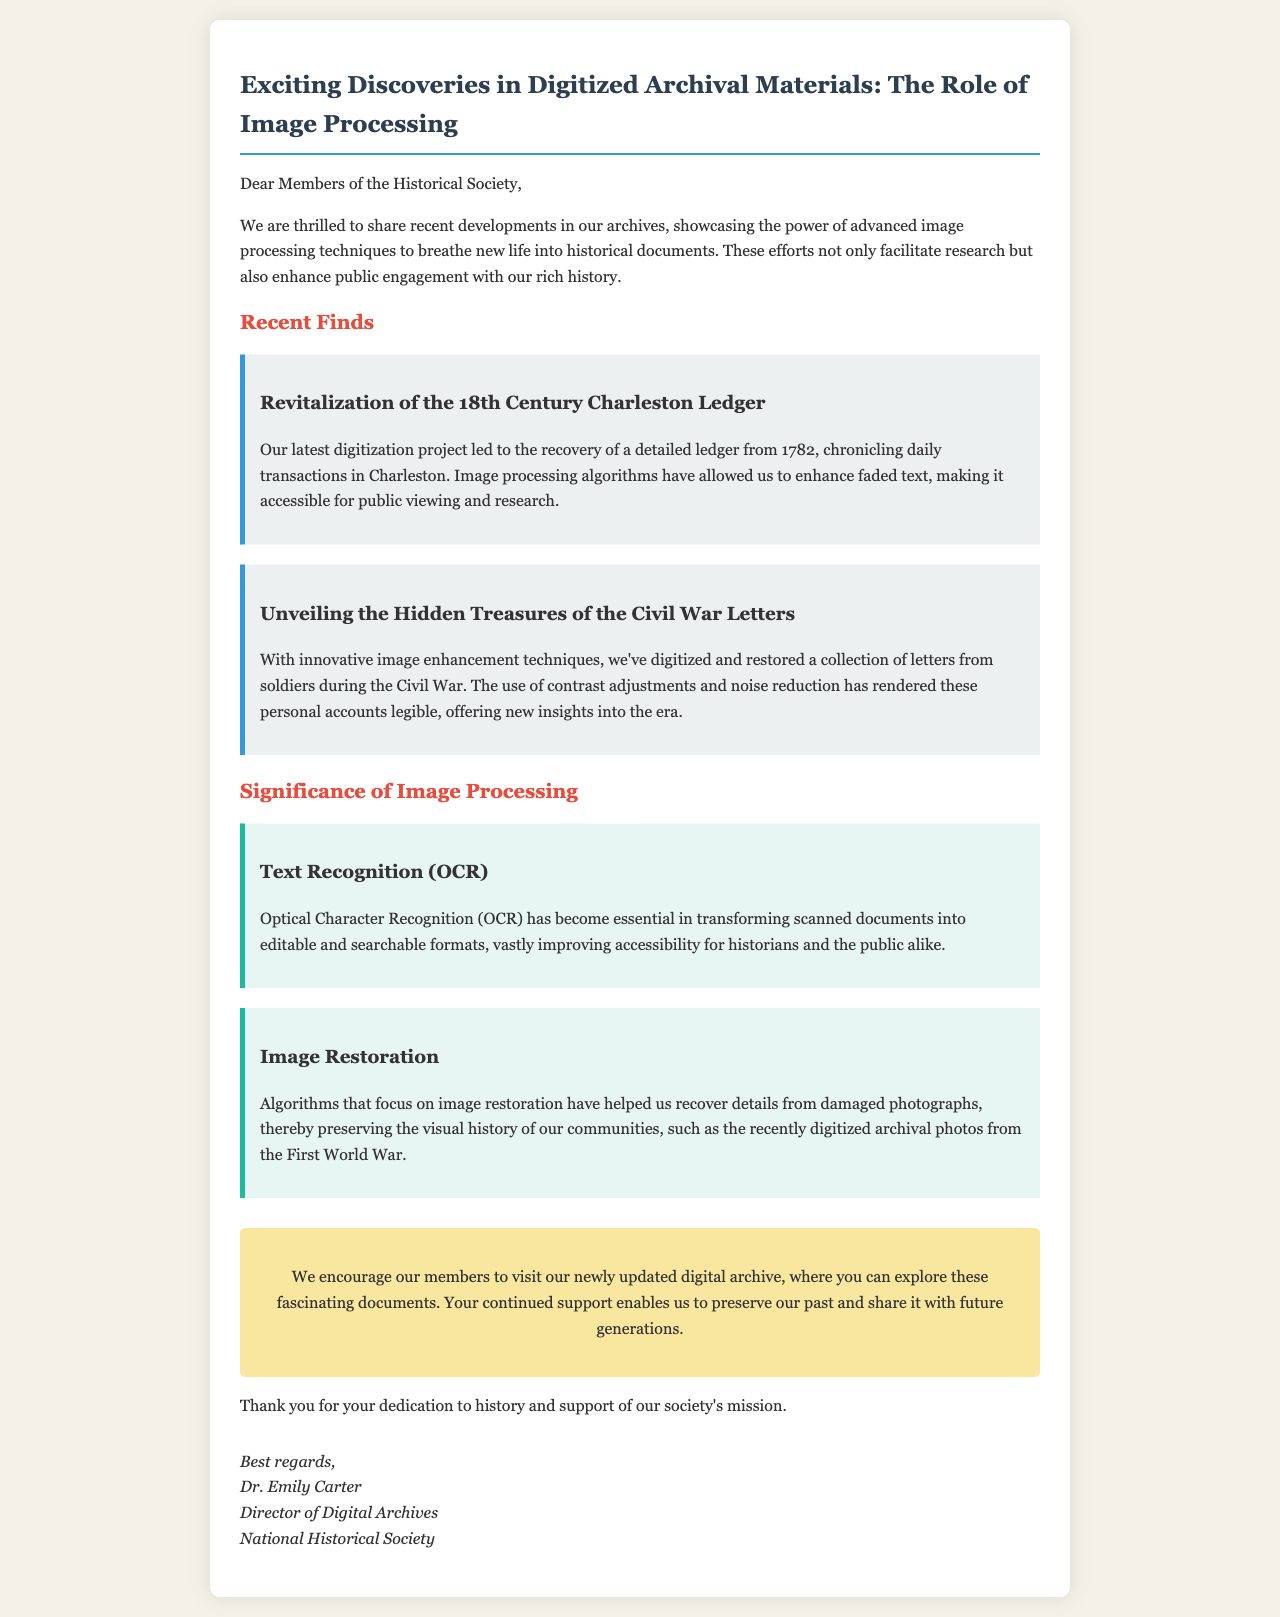What historical document was recently revitalized? The document revitalized was a ledger from 1782.
Answer: ledger from 1782 What recent collection was digitized and restored regarding the Civil War? The collection digitized and restored was letters from soldiers.
Answer: letters from soldiers What advanced technique has transformed scanned documents for better accessibility? The technique is Optical Character Recognition (OCR).
Answer: Optical Character Recognition (OCR) What year do the digitized archival photos from World War pertain to? The digitized archival photos pertain to the First World War.
Answer: First World War Who is the Director of Digital Archives at the National Historical Society? The Director of Digital Archives is Dr. Emily Carter.
Answer: Dr. Emily Carter What is the purpose of the newly updated digital archive mentioned in the email? The purpose is to explore fascinating documents.
Answer: explore fascinating documents How does image processing enhance public engagement with history? It enhances public engagement by making historical documents more accessible and understandable.
Answer: making historical documents more accessible and understandable 